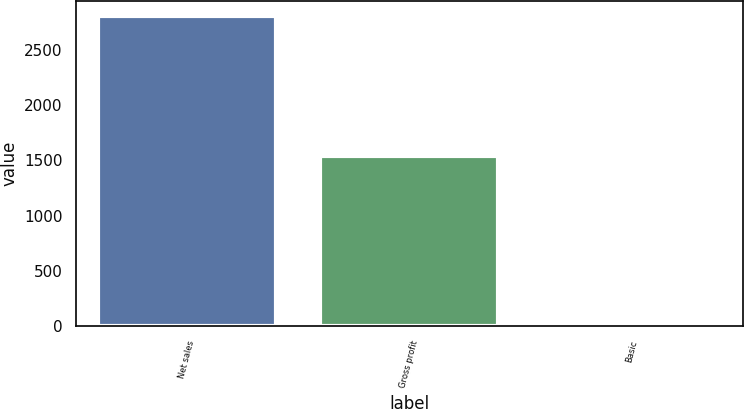Convert chart. <chart><loc_0><loc_0><loc_500><loc_500><bar_chart><fcel>Net sales<fcel>Gross profit<fcel>Basic<nl><fcel>2803.3<fcel>1537.1<fcel>0.53<nl></chart> 